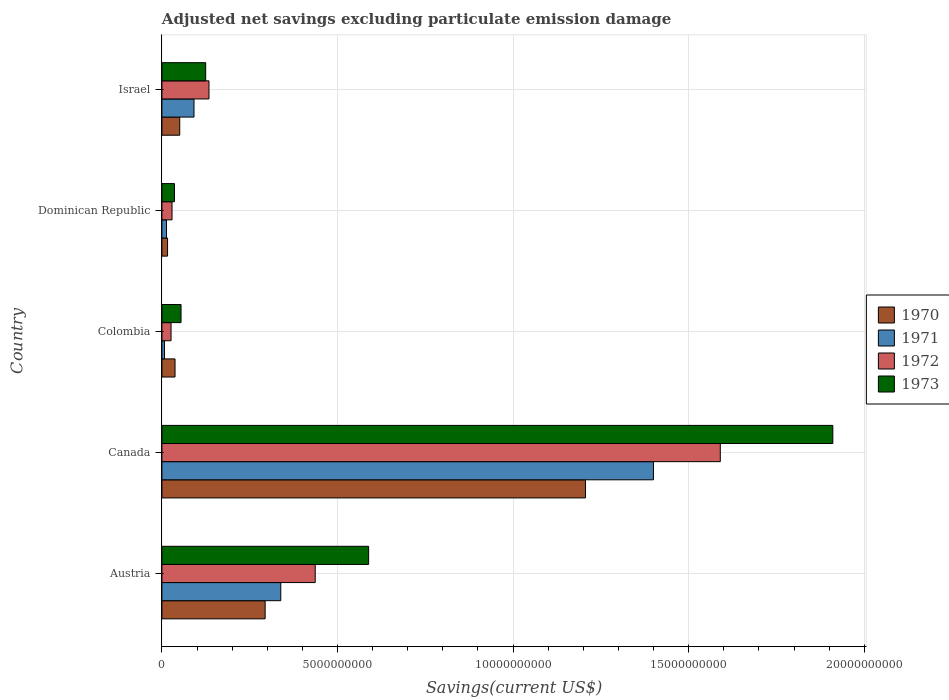How many different coloured bars are there?
Your answer should be very brief. 4. How many groups of bars are there?
Your answer should be compact. 5. Are the number of bars per tick equal to the number of legend labels?
Your response must be concise. Yes. Are the number of bars on each tick of the Y-axis equal?
Keep it short and to the point. Yes. How many bars are there on the 4th tick from the top?
Keep it short and to the point. 4. How many bars are there on the 5th tick from the bottom?
Your response must be concise. 4. What is the label of the 4th group of bars from the top?
Ensure brevity in your answer.  Canada. In how many cases, is the number of bars for a given country not equal to the number of legend labels?
Offer a very short reply. 0. What is the adjusted net savings in 1971 in Israel?
Ensure brevity in your answer.  9.14e+08. Across all countries, what is the maximum adjusted net savings in 1971?
Your answer should be very brief. 1.40e+1. Across all countries, what is the minimum adjusted net savings in 1970?
Offer a very short reply. 1.61e+08. In which country was the adjusted net savings in 1970 minimum?
Keep it short and to the point. Dominican Republic. What is the total adjusted net savings in 1971 in the graph?
Your answer should be very brief. 1.85e+1. What is the difference between the adjusted net savings in 1970 in Dominican Republic and that in Israel?
Your response must be concise. -3.47e+08. What is the difference between the adjusted net savings in 1970 in Austria and the adjusted net savings in 1971 in Israel?
Offer a terse response. 2.03e+09. What is the average adjusted net savings in 1970 per country?
Keep it short and to the point. 3.21e+09. What is the difference between the adjusted net savings in 1971 and adjusted net savings in 1972 in Dominican Republic?
Your answer should be compact. -1.57e+08. What is the ratio of the adjusted net savings in 1972 in Canada to that in Colombia?
Your answer should be very brief. 61.09. Is the adjusted net savings in 1971 in Austria less than that in Colombia?
Provide a short and direct response. No. What is the difference between the highest and the second highest adjusted net savings in 1973?
Give a very brief answer. 1.32e+1. What is the difference between the highest and the lowest adjusted net savings in 1971?
Make the answer very short. 1.39e+1. In how many countries, is the adjusted net savings in 1972 greater than the average adjusted net savings in 1972 taken over all countries?
Make the answer very short. 1. What does the 4th bar from the top in Canada represents?
Provide a short and direct response. 1970. Is it the case that in every country, the sum of the adjusted net savings in 1972 and adjusted net savings in 1970 is greater than the adjusted net savings in 1971?
Your answer should be compact. Yes. How many bars are there?
Your response must be concise. 20. Are the values on the major ticks of X-axis written in scientific E-notation?
Make the answer very short. No. Does the graph contain any zero values?
Offer a terse response. No. Does the graph contain grids?
Provide a short and direct response. Yes. What is the title of the graph?
Your answer should be very brief. Adjusted net savings excluding particulate emission damage. Does "1960" appear as one of the legend labels in the graph?
Provide a short and direct response. No. What is the label or title of the X-axis?
Your answer should be compact. Savings(current US$). What is the label or title of the Y-axis?
Your response must be concise. Country. What is the Savings(current US$) in 1970 in Austria?
Keep it short and to the point. 2.94e+09. What is the Savings(current US$) of 1971 in Austria?
Offer a terse response. 3.38e+09. What is the Savings(current US$) in 1972 in Austria?
Your answer should be compact. 4.37e+09. What is the Savings(current US$) of 1973 in Austria?
Ensure brevity in your answer.  5.89e+09. What is the Savings(current US$) in 1970 in Canada?
Give a very brief answer. 1.21e+1. What is the Savings(current US$) of 1971 in Canada?
Make the answer very short. 1.40e+1. What is the Savings(current US$) of 1972 in Canada?
Provide a succinct answer. 1.59e+1. What is the Savings(current US$) in 1973 in Canada?
Provide a short and direct response. 1.91e+1. What is the Savings(current US$) of 1970 in Colombia?
Keep it short and to the point. 3.74e+08. What is the Savings(current US$) of 1971 in Colombia?
Give a very brief answer. 7.46e+07. What is the Savings(current US$) in 1972 in Colombia?
Ensure brevity in your answer.  2.60e+08. What is the Savings(current US$) in 1973 in Colombia?
Keep it short and to the point. 5.45e+08. What is the Savings(current US$) of 1970 in Dominican Republic?
Provide a succinct answer. 1.61e+08. What is the Savings(current US$) in 1971 in Dominican Republic?
Offer a terse response. 1.32e+08. What is the Savings(current US$) in 1972 in Dominican Republic?
Your answer should be compact. 2.89e+08. What is the Savings(current US$) in 1973 in Dominican Republic?
Your answer should be very brief. 3.58e+08. What is the Savings(current US$) of 1970 in Israel?
Offer a terse response. 5.08e+08. What is the Savings(current US$) in 1971 in Israel?
Your answer should be compact. 9.14e+08. What is the Savings(current US$) of 1972 in Israel?
Make the answer very short. 1.34e+09. What is the Savings(current US$) of 1973 in Israel?
Provide a short and direct response. 1.25e+09. Across all countries, what is the maximum Savings(current US$) in 1970?
Your answer should be very brief. 1.21e+1. Across all countries, what is the maximum Savings(current US$) in 1971?
Give a very brief answer. 1.40e+1. Across all countries, what is the maximum Savings(current US$) of 1972?
Give a very brief answer. 1.59e+1. Across all countries, what is the maximum Savings(current US$) in 1973?
Keep it short and to the point. 1.91e+1. Across all countries, what is the minimum Savings(current US$) of 1970?
Ensure brevity in your answer.  1.61e+08. Across all countries, what is the minimum Savings(current US$) in 1971?
Ensure brevity in your answer.  7.46e+07. Across all countries, what is the minimum Savings(current US$) of 1972?
Offer a very short reply. 2.60e+08. Across all countries, what is the minimum Savings(current US$) in 1973?
Keep it short and to the point. 3.58e+08. What is the total Savings(current US$) of 1970 in the graph?
Give a very brief answer. 1.60e+1. What is the total Savings(current US$) of 1971 in the graph?
Your answer should be compact. 1.85e+1. What is the total Savings(current US$) in 1972 in the graph?
Provide a short and direct response. 2.22e+1. What is the total Savings(current US$) of 1973 in the graph?
Ensure brevity in your answer.  2.71e+1. What is the difference between the Savings(current US$) of 1970 in Austria and that in Canada?
Provide a succinct answer. -9.12e+09. What is the difference between the Savings(current US$) of 1971 in Austria and that in Canada?
Offer a very short reply. -1.06e+1. What is the difference between the Savings(current US$) of 1972 in Austria and that in Canada?
Offer a very short reply. -1.15e+1. What is the difference between the Savings(current US$) of 1973 in Austria and that in Canada?
Offer a very short reply. -1.32e+1. What is the difference between the Savings(current US$) of 1970 in Austria and that in Colombia?
Offer a very short reply. 2.57e+09. What is the difference between the Savings(current US$) of 1971 in Austria and that in Colombia?
Provide a succinct answer. 3.31e+09. What is the difference between the Savings(current US$) of 1972 in Austria and that in Colombia?
Your response must be concise. 4.11e+09. What is the difference between the Savings(current US$) in 1973 in Austria and that in Colombia?
Offer a terse response. 5.34e+09. What is the difference between the Savings(current US$) in 1970 in Austria and that in Dominican Republic?
Ensure brevity in your answer.  2.78e+09. What is the difference between the Savings(current US$) in 1971 in Austria and that in Dominican Republic?
Offer a very short reply. 3.25e+09. What is the difference between the Savings(current US$) of 1972 in Austria and that in Dominican Republic?
Your answer should be compact. 4.08e+09. What is the difference between the Savings(current US$) of 1973 in Austria and that in Dominican Republic?
Give a very brief answer. 5.53e+09. What is the difference between the Savings(current US$) of 1970 in Austria and that in Israel?
Make the answer very short. 2.43e+09. What is the difference between the Savings(current US$) of 1971 in Austria and that in Israel?
Your answer should be compact. 2.47e+09. What is the difference between the Savings(current US$) of 1972 in Austria and that in Israel?
Offer a very short reply. 3.02e+09. What is the difference between the Savings(current US$) in 1973 in Austria and that in Israel?
Provide a short and direct response. 4.64e+09. What is the difference between the Savings(current US$) in 1970 in Canada and that in Colombia?
Offer a terse response. 1.17e+1. What is the difference between the Savings(current US$) in 1971 in Canada and that in Colombia?
Provide a short and direct response. 1.39e+1. What is the difference between the Savings(current US$) of 1972 in Canada and that in Colombia?
Offer a terse response. 1.56e+1. What is the difference between the Savings(current US$) of 1973 in Canada and that in Colombia?
Give a very brief answer. 1.86e+1. What is the difference between the Savings(current US$) of 1970 in Canada and that in Dominican Republic?
Offer a terse response. 1.19e+1. What is the difference between the Savings(current US$) in 1971 in Canada and that in Dominican Republic?
Offer a very short reply. 1.39e+1. What is the difference between the Savings(current US$) in 1972 in Canada and that in Dominican Republic?
Your response must be concise. 1.56e+1. What is the difference between the Savings(current US$) of 1973 in Canada and that in Dominican Republic?
Offer a very short reply. 1.87e+1. What is the difference between the Savings(current US$) of 1970 in Canada and that in Israel?
Keep it short and to the point. 1.16e+1. What is the difference between the Savings(current US$) in 1971 in Canada and that in Israel?
Provide a short and direct response. 1.31e+1. What is the difference between the Savings(current US$) of 1972 in Canada and that in Israel?
Make the answer very short. 1.46e+1. What is the difference between the Savings(current US$) in 1973 in Canada and that in Israel?
Ensure brevity in your answer.  1.79e+1. What is the difference between the Savings(current US$) of 1970 in Colombia and that in Dominican Republic?
Ensure brevity in your answer.  2.13e+08. What is the difference between the Savings(current US$) of 1971 in Colombia and that in Dominican Republic?
Your answer should be compact. -5.69e+07. What is the difference between the Savings(current US$) of 1972 in Colombia and that in Dominican Republic?
Ensure brevity in your answer.  -2.84e+07. What is the difference between the Savings(current US$) of 1973 in Colombia and that in Dominican Republic?
Make the answer very short. 1.87e+08. What is the difference between the Savings(current US$) in 1970 in Colombia and that in Israel?
Keep it short and to the point. -1.34e+08. What is the difference between the Savings(current US$) of 1971 in Colombia and that in Israel?
Offer a terse response. -8.40e+08. What is the difference between the Savings(current US$) in 1972 in Colombia and that in Israel?
Offer a terse response. -1.08e+09. What is the difference between the Savings(current US$) of 1973 in Colombia and that in Israel?
Make the answer very short. -7.02e+08. What is the difference between the Savings(current US$) in 1970 in Dominican Republic and that in Israel?
Offer a very short reply. -3.47e+08. What is the difference between the Savings(current US$) of 1971 in Dominican Republic and that in Israel?
Give a very brief answer. -7.83e+08. What is the difference between the Savings(current US$) in 1972 in Dominican Republic and that in Israel?
Your answer should be compact. -1.05e+09. What is the difference between the Savings(current US$) of 1973 in Dominican Republic and that in Israel?
Make the answer very short. -8.89e+08. What is the difference between the Savings(current US$) in 1970 in Austria and the Savings(current US$) in 1971 in Canada?
Provide a succinct answer. -1.11e+1. What is the difference between the Savings(current US$) of 1970 in Austria and the Savings(current US$) of 1972 in Canada?
Offer a very short reply. -1.30e+1. What is the difference between the Savings(current US$) in 1970 in Austria and the Savings(current US$) in 1973 in Canada?
Keep it short and to the point. -1.62e+1. What is the difference between the Savings(current US$) in 1971 in Austria and the Savings(current US$) in 1972 in Canada?
Provide a succinct answer. -1.25e+1. What is the difference between the Savings(current US$) of 1971 in Austria and the Savings(current US$) of 1973 in Canada?
Keep it short and to the point. -1.57e+1. What is the difference between the Savings(current US$) in 1972 in Austria and the Savings(current US$) in 1973 in Canada?
Your response must be concise. -1.47e+1. What is the difference between the Savings(current US$) in 1970 in Austria and the Savings(current US$) in 1971 in Colombia?
Your answer should be very brief. 2.87e+09. What is the difference between the Savings(current US$) of 1970 in Austria and the Savings(current US$) of 1972 in Colombia?
Offer a very short reply. 2.68e+09. What is the difference between the Savings(current US$) in 1970 in Austria and the Savings(current US$) in 1973 in Colombia?
Provide a short and direct response. 2.40e+09. What is the difference between the Savings(current US$) in 1971 in Austria and the Savings(current US$) in 1972 in Colombia?
Provide a succinct answer. 3.12e+09. What is the difference between the Savings(current US$) of 1971 in Austria and the Savings(current US$) of 1973 in Colombia?
Keep it short and to the point. 2.84e+09. What is the difference between the Savings(current US$) in 1972 in Austria and the Savings(current US$) in 1973 in Colombia?
Give a very brief answer. 3.82e+09. What is the difference between the Savings(current US$) in 1970 in Austria and the Savings(current US$) in 1971 in Dominican Republic?
Your answer should be compact. 2.81e+09. What is the difference between the Savings(current US$) of 1970 in Austria and the Savings(current US$) of 1972 in Dominican Republic?
Make the answer very short. 2.65e+09. What is the difference between the Savings(current US$) in 1970 in Austria and the Savings(current US$) in 1973 in Dominican Republic?
Your answer should be compact. 2.58e+09. What is the difference between the Savings(current US$) in 1971 in Austria and the Savings(current US$) in 1972 in Dominican Republic?
Provide a succinct answer. 3.10e+09. What is the difference between the Savings(current US$) in 1971 in Austria and the Savings(current US$) in 1973 in Dominican Republic?
Your answer should be compact. 3.03e+09. What is the difference between the Savings(current US$) of 1972 in Austria and the Savings(current US$) of 1973 in Dominican Republic?
Provide a short and direct response. 4.01e+09. What is the difference between the Savings(current US$) of 1970 in Austria and the Savings(current US$) of 1971 in Israel?
Your answer should be compact. 2.03e+09. What is the difference between the Savings(current US$) in 1970 in Austria and the Savings(current US$) in 1972 in Israel?
Your answer should be compact. 1.60e+09. What is the difference between the Savings(current US$) in 1970 in Austria and the Savings(current US$) in 1973 in Israel?
Keep it short and to the point. 1.69e+09. What is the difference between the Savings(current US$) in 1971 in Austria and the Savings(current US$) in 1972 in Israel?
Offer a very short reply. 2.04e+09. What is the difference between the Savings(current US$) of 1971 in Austria and the Savings(current US$) of 1973 in Israel?
Keep it short and to the point. 2.14e+09. What is the difference between the Savings(current US$) in 1972 in Austria and the Savings(current US$) in 1973 in Israel?
Provide a short and direct response. 3.12e+09. What is the difference between the Savings(current US$) in 1970 in Canada and the Savings(current US$) in 1971 in Colombia?
Your answer should be very brief. 1.20e+1. What is the difference between the Savings(current US$) of 1970 in Canada and the Savings(current US$) of 1972 in Colombia?
Provide a succinct answer. 1.18e+1. What is the difference between the Savings(current US$) in 1970 in Canada and the Savings(current US$) in 1973 in Colombia?
Make the answer very short. 1.15e+1. What is the difference between the Savings(current US$) of 1971 in Canada and the Savings(current US$) of 1972 in Colombia?
Offer a terse response. 1.37e+1. What is the difference between the Savings(current US$) in 1971 in Canada and the Savings(current US$) in 1973 in Colombia?
Provide a succinct answer. 1.35e+1. What is the difference between the Savings(current US$) of 1972 in Canada and the Savings(current US$) of 1973 in Colombia?
Your answer should be compact. 1.54e+1. What is the difference between the Savings(current US$) in 1970 in Canada and the Savings(current US$) in 1971 in Dominican Republic?
Keep it short and to the point. 1.19e+1. What is the difference between the Savings(current US$) in 1970 in Canada and the Savings(current US$) in 1972 in Dominican Republic?
Provide a succinct answer. 1.18e+1. What is the difference between the Savings(current US$) in 1970 in Canada and the Savings(current US$) in 1973 in Dominican Republic?
Your response must be concise. 1.17e+1. What is the difference between the Savings(current US$) in 1971 in Canada and the Savings(current US$) in 1972 in Dominican Republic?
Offer a very short reply. 1.37e+1. What is the difference between the Savings(current US$) in 1971 in Canada and the Savings(current US$) in 1973 in Dominican Republic?
Your response must be concise. 1.36e+1. What is the difference between the Savings(current US$) in 1972 in Canada and the Savings(current US$) in 1973 in Dominican Republic?
Offer a terse response. 1.55e+1. What is the difference between the Savings(current US$) in 1970 in Canada and the Savings(current US$) in 1971 in Israel?
Keep it short and to the point. 1.11e+1. What is the difference between the Savings(current US$) in 1970 in Canada and the Savings(current US$) in 1972 in Israel?
Provide a succinct answer. 1.07e+1. What is the difference between the Savings(current US$) of 1970 in Canada and the Savings(current US$) of 1973 in Israel?
Your answer should be very brief. 1.08e+1. What is the difference between the Savings(current US$) of 1971 in Canada and the Savings(current US$) of 1972 in Israel?
Your response must be concise. 1.27e+1. What is the difference between the Savings(current US$) in 1971 in Canada and the Savings(current US$) in 1973 in Israel?
Offer a terse response. 1.27e+1. What is the difference between the Savings(current US$) of 1972 in Canada and the Savings(current US$) of 1973 in Israel?
Your answer should be very brief. 1.47e+1. What is the difference between the Savings(current US$) in 1970 in Colombia and the Savings(current US$) in 1971 in Dominican Republic?
Give a very brief answer. 2.42e+08. What is the difference between the Savings(current US$) in 1970 in Colombia and the Savings(current US$) in 1972 in Dominican Republic?
Offer a terse response. 8.52e+07. What is the difference between the Savings(current US$) of 1970 in Colombia and the Savings(current US$) of 1973 in Dominican Republic?
Your answer should be very brief. 1.57e+07. What is the difference between the Savings(current US$) of 1971 in Colombia and the Savings(current US$) of 1972 in Dominican Republic?
Make the answer very short. -2.14e+08. What is the difference between the Savings(current US$) in 1971 in Colombia and the Savings(current US$) in 1973 in Dominican Republic?
Offer a very short reply. -2.84e+08. What is the difference between the Savings(current US$) of 1972 in Colombia and the Savings(current US$) of 1973 in Dominican Republic?
Provide a succinct answer. -9.79e+07. What is the difference between the Savings(current US$) in 1970 in Colombia and the Savings(current US$) in 1971 in Israel?
Give a very brief answer. -5.40e+08. What is the difference between the Savings(current US$) in 1970 in Colombia and the Savings(current US$) in 1972 in Israel?
Offer a terse response. -9.67e+08. What is the difference between the Savings(current US$) in 1970 in Colombia and the Savings(current US$) in 1973 in Israel?
Offer a very short reply. -8.73e+08. What is the difference between the Savings(current US$) of 1971 in Colombia and the Savings(current US$) of 1972 in Israel?
Provide a short and direct response. -1.27e+09. What is the difference between the Savings(current US$) of 1971 in Colombia and the Savings(current US$) of 1973 in Israel?
Provide a short and direct response. -1.17e+09. What is the difference between the Savings(current US$) in 1972 in Colombia and the Savings(current US$) in 1973 in Israel?
Your response must be concise. -9.87e+08. What is the difference between the Savings(current US$) in 1970 in Dominican Republic and the Savings(current US$) in 1971 in Israel?
Keep it short and to the point. -7.53e+08. What is the difference between the Savings(current US$) of 1970 in Dominican Republic and the Savings(current US$) of 1972 in Israel?
Make the answer very short. -1.18e+09. What is the difference between the Savings(current US$) of 1970 in Dominican Republic and the Savings(current US$) of 1973 in Israel?
Provide a succinct answer. -1.09e+09. What is the difference between the Savings(current US$) of 1971 in Dominican Republic and the Savings(current US$) of 1972 in Israel?
Offer a very short reply. -1.21e+09. What is the difference between the Savings(current US$) of 1971 in Dominican Republic and the Savings(current US$) of 1973 in Israel?
Offer a very short reply. -1.12e+09. What is the difference between the Savings(current US$) in 1972 in Dominican Republic and the Savings(current US$) in 1973 in Israel?
Your answer should be very brief. -9.58e+08. What is the average Savings(current US$) in 1970 per country?
Your answer should be compact. 3.21e+09. What is the average Savings(current US$) of 1971 per country?
Offer a terse response. 3.70e+09. What is the average Savings(current US$) of 1972 per country?
Provide a succinct answer. 4.43e+09. What is the average Savings(current US$) of 1973 per country?
Provide a succinct answer. 5.43e+09. What is the difference between the Savings(current US$) of 1970 and Savings(current US$) of 1971 in Austria?
Ensure brevity in your answer.  -4.45e+08. What is the difference between the Savings(current US$) of 1970 and Savings(current US$) of 1972 in Austria?
Your answer should be compact. -1.43e+09. What is the difference between the Savings(current US$) of 1970 and Savings(current US$) of 1973 in Austria?
Give a very brief answer. -2.95e+09. What is the difference between the Savings(current US$) of 1971 and Savings(current US$) of 1972 in Austria?
Keep it short and to the point. -9.81e+08. What is the difference between the Savings(current US$) in 1971 and Savings(current US$) in 1973 in Austria?
Give a very brief answer. -2.50e+09. What is the difference between the Savings(current US$) of 1972 and Savings(current US$) of 1973 in Austria?
Ensure brevity in your answer.  -1.52e+09. What is the difference between the Savings(current US$) in 1970 and Savings(current US$) in 1971 in Canada?
Provide a short and direct response. -1.94e+09. What is the difference between the Savings(current US$) in 1970 and Savings(current US$) in 1972 in Canada?
Make the answer very short. -3.84e+09. What is the difference between the Savings(current US$) of 1970 and Savings(current US$) of 1973 in Canada?
Your answer should be very brief. -7.04e+09. What is the difference between the Savings(current US$) of 1971 and Savings(current US$) of 1972 in Canada?
Make the answer very short. -1.90e+09. What is the difference between the Savings(current US$) of 1971 and Savings(current US$) of 1973 in Canada?
Make the answer very short. -5.11e+09. What is the difference between the Savings(current US$) in 1972 and Savings(current US$) in 1973 in Canada?
Offer a very short reply. -3.20e+09. What is the difference between the Savings(current US$) of 1970 and Savings(current US$) of 1971 in Colombia?
Your answer should be very brief. 2.99e+08. What is the difference between the Savings(current US$) of 1970 and Savings(current US$) of 1972 in Colombia?
Offer a terse response. 1.14e+08. What is the difference between the Savings(current US$) of 1970 and Savings(current US$) of 1973 in Colombia?
Provide a succinct answer. -1.71e+08. What is the difference between the Savings(current US$) in 1971 and Savings(current US$) in 1972 in Colombia?
Offer a terse response. -1.86e+08. What is the difference between the Savings(current US$) of 1971 and Savings(current US$) of 1973 in Colombia?
Offer a terse response. -4.70e+08. What is the difference between the Savings(current US$) of 1972 and Savings(current US$) of 1973 in Colombia?
Provide a short and direct response. -2.85e+08. What is the difference between the Savings(current US$) of 1970 and Savings(current US$) of 1971 in Dominican Republic?
Keep it short and to the point. 2.96e+07. What is the difference between the Savings(current US$) of 1970 and Savings(current US$) of 1972 in Dominican Republic?
Offer a very short reply. -1.28e+08. What is the difference between the Savings(current US$) in 1970 and Savings(current US$) in 1973 in Dominican Republic?
Provide a short and direct response. -1.97e+08. What is the difference between the Savings(current US$) of 1971 and Savings(current US$) of 1972 in Dominican Republic?
Keep it short and to the point. -1.57e+08. What is the difference between the Savings(current US$) in 1971 and Savings(current US$) in 1973 in Dominican Republic?
Make the answer very short. -2.27e+08. What is the difference between the Savings(current US$) in 1972 and Savings(current US$) in 1973 in Dominican Republic?
Offer a very short reply. -6.95e+07. What is the difference between the Savings(current US$) in 1970 and Savings(current US$) in 1971 in Israel?
Give a very brief answer. -4.06e+08. What is the difference between the Savings(current US$) of 1970 and Savings(current US$) of 1972 in Israel?
Give a very brief answer. -8.33e+08. What is the difference between the Savings(current US$) of 1970 and Savings(current US$) of 1973 in Israel?
Ensure brevity in your answer.  -7.39e+08. What is the difference between the Savings(current US$) of 1971 and Savings(current US$) of 1972 in Israel?
Offer a very short reply. -4.27e+08. What is the difference between the Savings(current US$) of 1971 and Savings(current US$) of 1973 in Israel?
Ensure brevity in your answer.  -3.33e+08. What is the difference between the Savings(current US$) in 1972 and Savings(current US$) in 1973 in Israel?
Give a very brief answer. 9.40e+07. What is the ratio of the Savings(current US$) of 1970 in Austria to that in Canada?
Offer a very short reply. 0.24. What is the ratio of the Savings(current US$) of 1971 in Austria to that in Canada?
Give a very brief answer. 0.24. What is the ratio of the Savings(current US$) of 1972 in Austria to that in Canada?
Your response must be concise. 0.27. What is the ratio of the Savings(current US$) of 1973 in Austria to that in Canada?
Your answer should be very brief. 0.31. What is the ratio of the Savings(current US$) in 1970 in Austria to that in Colombia?
Provide a succinct answer. 7.86. What is the ratio of the Savings(current US$) in 1971 in Austria to that in Colombia?
Your answer should be compact. 45.37. What is the ratio of the Savings(current US$) of 1972 in Austria to that in Colombia?
Offer a very short reply. 16.77. What is the ratio of the Savings(current US$) in 1973 in Austria to that in Colombia?
Your answer should be compact. 10.8. What is the ratio of the Savings(current US$) in 1970 in Austria to that in Dominican Republic?
Provide a short and direct response. 18.25. What is the ratio of the Savings(current US$) of 1971 in Austria to that in Dominican Republic?
Offer a terse response. 25.73. What is the ratio of the Savings(current US$) in 1972 in Austria to that in Dominican Republic?
Make the answer very short. 15.12. What is the ratio of the Savings(current US$) of 1973 in Austria to that in Dominican Republic?
Your answer should be very brief. 16.43. What is the ratio of the Savings(current US$) in 1970 in Austria to that in Israel?
Give a very brief answer. 5.79. What is the ratio of the Savings(current US$) of 1971 in Austria to that in Israel?
Your answer should be very brief. 3.7. What is the ratio of the Savings(current US$) in 1972 in Austria to that in Israel?
Your answer should be very brief. 3.26. What is the ratio of the Savings(current US$) in 1973 in Austria to that in Israel?
Offer a very short reply. 4.72. What is the ratio of the Savings(current US$) of 1970 in Canada to that in Colombia?
Offer a terse response. 32.26. What is the ratio of the Savings(current US$) of 1971 in Canada to that in Colombia?
Provide a short and direct response. 187.59. What is the ratio of the Savings(current US$) of 1972 in Canada to that in Colombia?
Your answer should be very brief. 61.09. What is the ratio of the Savings(current US$) in 1973 in Canada to that in Colombia?
Your answer should be compact. 35.07. What is the ratio of the Savings(current US$) of 1970 in Canada to that in Dominican Republic?
Provide a short and direct response. 74.87. What is the ratio of the Savings(current US$) of 1971 in Canada to that in Dominican Republic?
Offer a very short reply. 106.4. What is the ratio of the Savings(current US$) in 1972 in Canada to that in Dominican Republic?
Make the answer very short. 55.08. What is the ratio of the Savings(current US$) of 1973 in Canada to that in Dominican Republic?
Your response must be concise. 53.33. What is the ratio of the Savings(current US$) of 1970 in Canada to that in Israel?
Your response must be concise. 23.75. What is the ratio of the Savings(current US$) of 1971 in Canada to that in Israel?
Offer a terse response. 15.31. What is the ratio of the Savings(current US$) of 1972 in Canada to that in Israel?
Make the answer very short. 11.86. What is the ratio of the Savings(current US$) in 1973 in Canada to that in Israel?
Provide a short and direct response. 15.32. What is the ratio of the Savings(current US$) in 1970 in Colombia to that in Dominican Republic?
Offer a very short reply. 2.32. What is the ratio of the Savings(current US$) in 1971 in Colombia to that in Dominican Republic?
Your answer should be compact. 0.57. What is the ratio of the Savings(current US$) in 1972 in Colombia to that in Dominican Republic?
Give a very brief answer. 0.9. What is the ratio of the Savings(current US$) of 1973 in Colombia to that in Dominican Republic?
Give a very brief answer. 1.52. What is the ratio of the Savings(current US$) of 1970 in Colombia to that in Israel?
Your answer should be compact. 0.74. What is the ratio of the Savings(current US$) in 1971 in Colombia to that in Israel?
Provide a succinct answer. 0.08. What is the ratio of the Savings(current US$) in 1972 in Colombia to that in Israel?
Your response must be concise. 0.19. What is the ratio of the Savings(current US$) in 1973 in Colombia to that in Israel?
Provide a short and direct response. 0.44. What is the ratio of the Savings(current US$) of 1970 in Dominican Republic to that in Israel?
Give a very brief answer. 0.32. What is the ratio of the Savings(current US$) in 1971 in Dominican Republic to that in Israel?
Your answer should be very brief. 0.14. What is the ratio of the Savings(current US$) of 1972 in Dominican Republic to that in Israel?
Keep it short and to the point. 0.22. What is the ratio of the Savings(current US$) in 1973 in Dominican Republic to that in Israel?
Offer a terse response. 0.29. What is the difference between the highest and the second highest Savings(current US$) of 1970?
Ensure brevity in your answer.  9.12e+09. What is the difference between the highest and the second highest Savings(current US$) in 1971?
Make the answer very short. 1.06e+1. What is the difference between the highest and the second highest Savings(current US$) of 1972?
Provide a succinct answer. 1.15e+1. What is the difference between the highest and the second highest Savings(current US$) in 1973?
Offer a very short reply. 1.32e+1. What is the difference between the highest and the lowest Savings(current US$) of 1970?
Keep it short and to the point. 1.19e+1. What is the difference between the highest and the lowest Savings(current US$) of 1971?
Your answer should be very brief. 1.39e+1. What is the difference between the highest and the lowest Savings(current US$) of 1972?
Provide a short and direct response. 1.56e+1. What is the difference between the highest and the lowest Savings(current US$) in 1973?
Provide a succinct answer. 1.87e+1. 